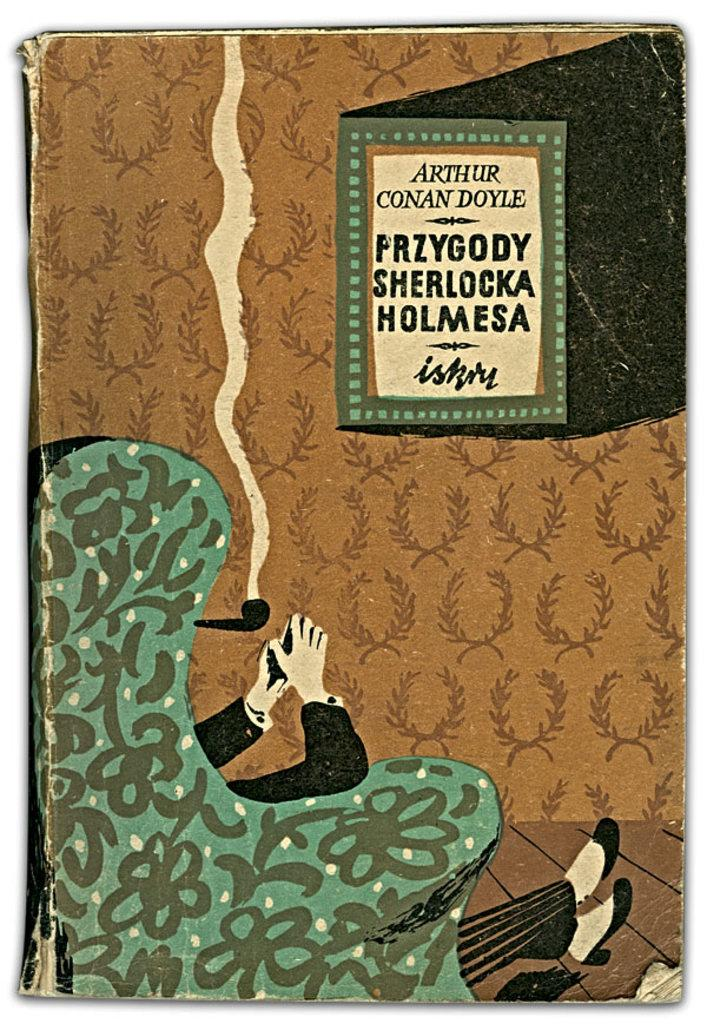What object can be seen in the image? There is a book in the image. What is the person in the image doing? A person is sitting on a chair in the image. How is the person interacting with the book? The person is on the book. What can be read on the book? There is text visible on the book. What type of oil is being used by the person sitting on the book? There is no oil present in the image, and the person is not using any oil. How many legs does the book have in the image? Books do not have legs; they are flat objects. 